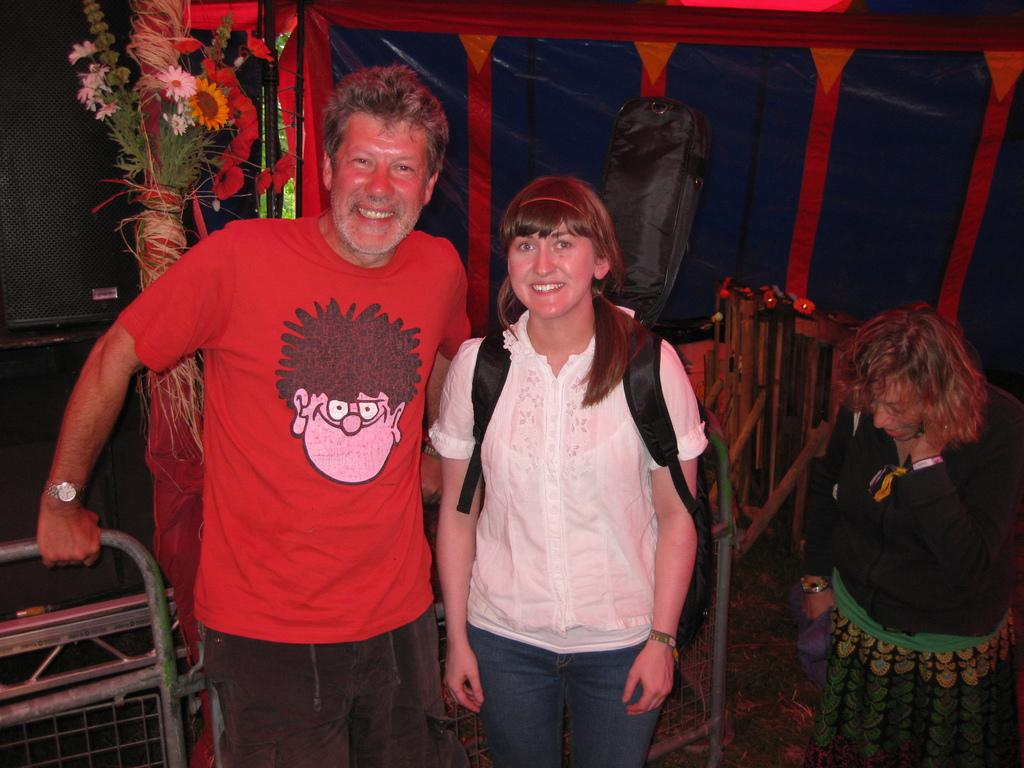How many people are in the image? There are three persons standing in the image. Where are the two persons on the left side located? The two persons on the left side are on the left side of the image. What expressions do the two persons on the left side have? The two persons on the left side are smiling. What can be seen in the background of the image? There are flowers in the background of the image. What type of shock can be seen affecting the person on the right side in the image? There is no shock present in the image; all three persons are standing and appear to be in a normal state. 